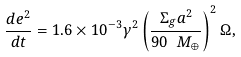<formula> <loc_0><loc_0><loc_500><loc_500>\frac { d e ^ { 2 } } { d t } = 1 . 6 \times 1 0 ^ { - 3 } \gamma ^ { 2 } \left ( \frac { \Sigma _ { g } a ^ { 2 } } { 9 0 \ M _ { \oplus } } \right ) ^ { 2 } \Omega ,</formula> 